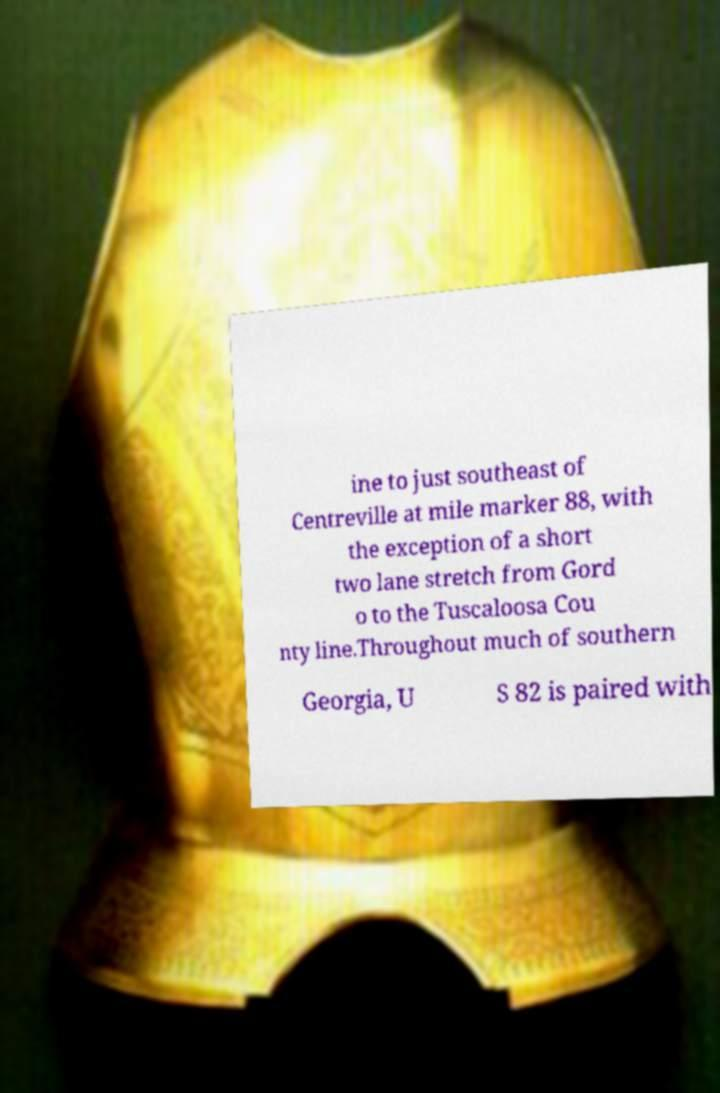Please identify and transcribe the text found in this image. ine to just southeast of Centreville at mile marker 88, with the exception of a short two lane stretch from Gord o to the Tuscaloosa Cou nty line.Throughout much of southern Georgia, U S 82 is paired with 